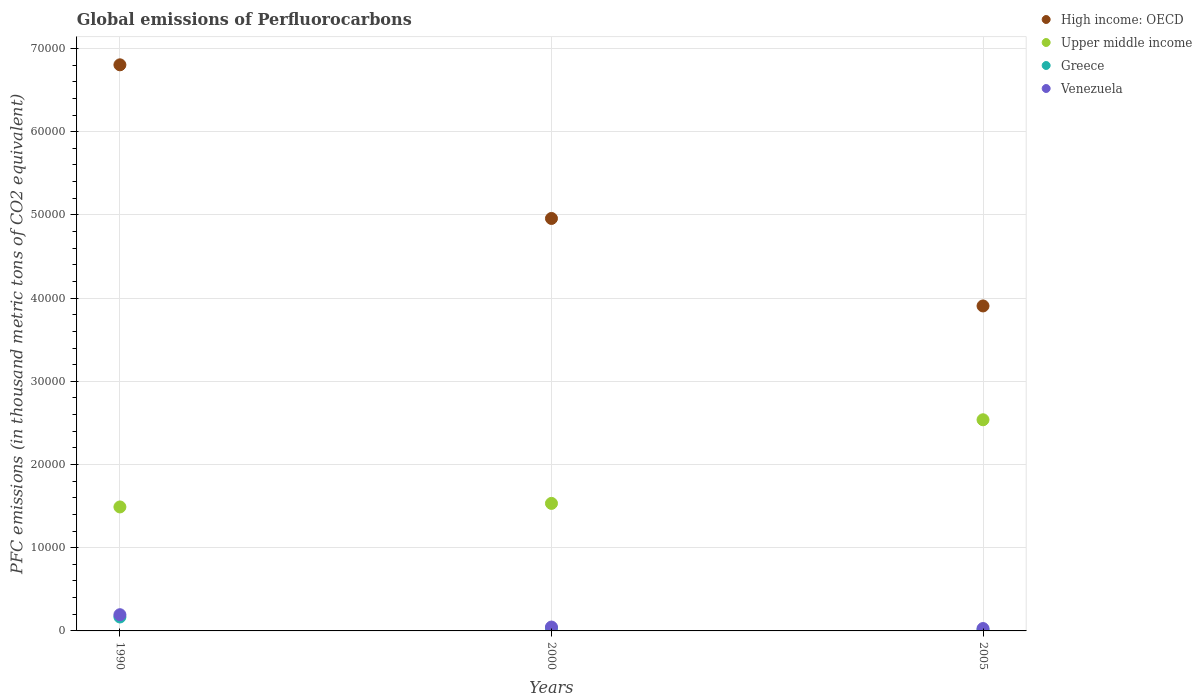Is the number of dotlines equal to the number of legend labels?
Ensure brevity in your answer.  Yes. What is the global emissions of Perfluorocarbons in Greece in 2005?
Offer a very short reply. 137.5. Across all years, what is the maximum global emissions of Perfluorocarbons in High income: OECD?
Give a very brief answer. 6.80e+04. Across all years, what is the minimum global emissions of Perfluorocarbons in High income: OECD?
Ensure brevity in your answer.  3.91e+04. In which year was the global emissions of Perfluorocarbons in Venezuela maximum?
Your response must be concise. 1990. What is the total global emissions of Perfluorocarbons in Upper middle income in the graph?
Your answer should be compact. 5.56e+04. What is the difference between the global emissions of Perfluorocarbons in High income: OECD in 1990 and that in 2005?
Provide a succinct answer. 2.90e+04. What is the difference between the global emissions of Perfluorocarbons in Upper middle income in 2005 and the global emissions of Perfluorocarbons in Venezuela in 2000?
Your response must be concise. 2.49e+04. What is the average global emissions of Perfluorocarbons in High income: OECD per year?
Make the answer very short. 5.22e+04. In the year 1990, what is the difference between the global emissions of Perfluorocarbons in High income: OECD and global emissions of Perfluorocarbons in Greece?
Give a very brief answer. 6.64e+04. In how many years, is the global emissions of Perfluorocarbons in Upper middle income greater than 8000 thousand metric tons?
Provide a succinct answer. 3. What is the ratio of the global emissions of Perfluorocarbons in Venezuela in 1990 to that in 2000?
Make the answer very short. 4.19. Is the global emissions of Perfluorocarbons in High income: OECD in 1990 less than that in 2000?
Make the answer very short. No. What is the difference between the highest and the second highest global emissions of Perfluorocarbons in Upper middle income?
Provide a short and direct response. 1.01e+04. What is the difference between the highest and the lowest global emissions of Perfluorocarbons in Upper middle income?
Your response must be concise. 1.05e+04. Is it the case that in every year, the sum of the global emissions of Perfluorocarbons in High income: OECD and global emissions of Perfluorocarbons in Upper middle income  is greater than the global emissions of Perfluorocarbons in Venezuela?
Offer a terse response. Yes. Does the global emissions of Perfluorocarbons in Upper middle income monotonically increase over the years?
Your response must be concise. Yes. How many years are there in the graph?
Provide a short and direct response. 3. What is the difference between two consecutive major ticks on the Y-axis?
Ensure brevity in your answer.  10000. Are the values on the major ticks of Y-axis written in scientific E-notation?
Your response must be concise. No. Does the graph contain any zero values?
Offer a terse response. No. Does the graph contain grids?
Your answer should be very brief. Yes. Where does the legend appear in the graph?
Your response must be concise. Top right. How are the legend labels stacked?
Keep it short and to the point. Vertical. What is the title of the graph?
Ensure brevity in your answer.  Global emissions of Perfluorocarbons. What is the label or title of the Y-axis?
Your answer should be very brief. PFC emissions (in thousand metric tons of CO2 equivalent). What is the PFC emissions (in thousand metric tons of CO2 equivalent) of High income: OECD in 1990?
Your response must be concise. 6.80e+04. What is the PFC emissions (in thousand metric tons of CO2 equivalent) in Upper middle income in 1990?
Provide a short and direct response. 1.49e+04. What is the PFC emissions (in thousand metric tons of CO2 equivalent) in Greece in 1990?
Offer a terse response. 1675.9. What is the PFC emissions (in thousand metric tons of CO2 equivalent) in Venezuela in 1990?
Offer a terse response. 1948.7. What is the PFC emissions (in thousand metric tons of CO2 equivalent) of High income: OECD in 2000?
Your answer should be compact. 4.96e+04. What is the PFC emissions (in thousand metric tons of CO2 equivalent) of Upper middle income in 2000?
Offer a terse response. 1.53e+04. What is the PFC emissions (in thousand metric tons of CO2 equivalent) of Greece in 2000?
Offer a very short reply. 311.3. What is the PFC emissions (in thousand metric tons of CO2 equivalent) in Venezuela in 2000?
Provide a short and direct response. 464.6. What is the PFC emissions (in thousand metric tons of CO2 equivalent) in High income: OECD in 2005?
Ensure brevity in your answer.  3.91e+04. What is the PFC emissions (in thousand metric tons of CO2 equivalent) of Upper middle income in 2005?
Provide a succinct answer. 2.54e+04. What is the PFC emissions (in thousand metric tons of CO2 equivalent) of Greece in 2005?
Your response must be concise. 137.5. What is the PFC emissions (in thousand metric tons of CO2 equivalent) in Venezuela in 2005?
Your response must be concise. 286.1. Across all years, what is the maximum PFC emissions (in thousand metric tons of CO2 equivalent) in High income: OECD?
Provide a short and direct response. 6.80e+04. Across all years, what is the maximum PFC emissions (in thousand metric tons of CO2 equivalent) of Upper middle income?
Give a very brief answer. 2.54e+04. Across all years, what is the maximum PFC emissions (in thousand metric tons of CO2 equivalent) of Greece?
Provide a succinct answer. 1675.9. Across all years, what is the maximum PFC emissions (in thousand metric tons of CO2 equivalent) of Venezuela?
Make the answer very short. 1948.7. Across all years, what is the minimum PFC emissions (in thousand metric tons of CO2 equivalent) of High income: OECD?
Offer a terse response. 3.91e+04. Across all years, what is the minimum PFC emissions (in thousand metric tons of CO2 equivalent) of Upper middle income?
Your answer should be compact. 1.49e+04. Across all years, what is the minimum PFC emissions (in thousand metric tons of CO2 equivalent) of Greece?
Your answer should be very brief. 137.5. Across all years, what is the minimum PFC emissions (in thousand metric tons of CO2 equivalent) in Venezuela?
Ensure brevity in your answer.  286.1. What is the total PFC emissions (in thousand metric tons of CO2 equivalent) of High income: OECD in the graph?
Offer a terse response. 1.57e+05. What is the total PFC emissions (in thousand metric tons of CO2 equivalent) of Upper middle income in the graph?
Your answer should be compact. 5.56e+04. What is the total PFC emissions (in thousand metric tons of CO2 equivalent) of Greece in the graph?
Offer a terse response. 2124.7. What is the total PFC emissions (in thousand metric tons of CO2 equivalent) of Venezuela in the graph?
Offer a terse response. 2699.4. What is the difference between the PFC emissions (in thousand metric tons of CO2 equivalent) of High income: OECD in 1990 and that in 2000?
Provide a short and direct response. 1.85e+04. What is the difference between the PFC emissions (in thousand metric tons of CO2 equivalent) in Upper middle income in 1990 and that in 2000?
Provide a succinct answer. -426.2. What is the difference between the PFC emissions (in thousand metric tons of CO2 equivalent) in Greece in 1990 and that in 2000?
Make the answer very short. 1364.6. What is the difference between the PFC emissions (in thousand metric tons of CO2 equivalent) in Venezuela in 1990 and that in 2000?
Make the answer very short. 1484.1. What is the difference between the PFC emissions (in thousand metric tons of CO2 equivalent) of High income: OECD in 1990 and that in 2005?
Make the answer very short. 2.90e+04. What is the difference between the PFC emissions (in thousand metric tons of CO2 equivalent) in Upper middle income in 1990 and that in 2005?
Provide a succinct answer. -1.05e+04. What is the difference between the PFC emissions (in thousand metric tons of CO2 equivalent) of Greece in 1990 and that in 2005?
Provide a succinct answer. 1538.4. What is the difference between the PFC emissions (in thousand metric tons of CO2 equivalent) in Venezuela in 1990 and that in 2005?
Offer a terse response. 1662.6. What is the difference between the PFC emissions (in thousand metric tons of CO2 equivalent) in High income: OECD in 2000 and that in 2005?
Offer a terse response. 1.05e+04. What is the difference between the PFC emissions (in thousand metric tons of CO2 equivalent) of Upper middle income in 2000 and that in 2005?
Offer a terse response. -1.01e+04. What is the difference between the PFC emissions (in thousand metric tons of CO2 equivalent) in Greece in 2000 and that in 2005?
Provide a succinct answer. 173.8. What is the difference between the PFC emissions (in thousand metric tons of CO2 equivalent) of Venezuela in 2000 and that in 2005?
Give a very brief answer. 178.5. What is the difference between the PFC emissions (in thousand metric tons of CO2 equivalent) in High income: OECD in 1990 and the PFC emissions (in thousand metric tons of CO2 equivalent) in Upper middle income in 2000?
Give a very brief answer. 5.27e+04. What is the difference between the PFC emissions (in thousand metric tons of CO2 equivalent) of High income: OECD in 1990 and the PFC emissions (in thousand metric tons of CO2 equivalent) of Greece in 2000?
Offer a very short reply. 6.77e+04. What is the difference between the PFC emissions (in thousand metric tons of CO2 equivalent) of High income: OECD in 1990 and the PFC emissions (in thousand metric tons of CO2 equivalent) of Venezuela in 2000?
Offer a very short reply. 6.76e+04. What is the difference between the PFC emissions (in thousand metric tons of CO2 equivalent) of Upper middle income in 1990 and the PFC emissions (in thousand metric tons of CO2 equivalent) of Greece in 2000?
Ensure brevity in your answer.  1.46e+04. What is the difference between the PFC emissions (in thousand metric tons of CO2 equivalent) of Upper middle income in 1990 and the PFC emissions (in thousand metric tons of CO2 equivalent) of Venezuela in 2000?
Provide a succinct answer. 1.44e+04. What is the difference between the PFC emissions (in thousand metric tons of CO2 equivalent) of Greece in 1990 and the PFC emissions (in thousand metric tons of CO2 equivalent) of Venezuela in 2000?
Make the answer very short. 1211.3. What is the difference between the PFC emissions (in thousand metric tons of CO2 equivalent) in High income: OECD in 1990 and the PFC emissions (in thousand metric tons of CO2 equivalent) in Upper middle income in 2005?
Keep it short and to the point. 4.27e+04. What is the difference between the PFC emissions (in thousand metric tons of CO2 equivalent) in High income: OECD in 1990 and the PFC emissions (in thousand metric tons of CO2 equivalent) in Greece in 2005?
Keep it short and to the point. 6.79e+04. What is the difference between the PFC emissions (in thousand metric tons of CO2 equivalent) of High income: OECD in 1990 and the PFC emissions (in thousand metric tons of CO2 equivalent) of Venezuela in 2005?
Provide a short and direct response. 6.77e+04. What is the difference between the PFC emissions (in thousand metric tons of CO2 equivalent) in Upper middle income in 1990 and the PFC emissions (in thousand metric tons of CO2 equivalent) in Greece in 2005?
Your answer should be compact. 1.48e+04. What is the difference between the PFC emissions (in thousand metric tons of CO2 equivalent) in Upper middle income in 1990 and the PFC emissions (in thousand metric tons of CO2 equivalent) in Venezuela in 2005?
Your response must be concise. 1.46e+04. What is the difference between the PFC emissions (in thousand metric tons of CO2 equivalent) of Greece in 1990 and the PFC emissions (in thousand metric tons of CO2 equivalent) of Venezuela in 2005?
Keep it short and to the point. 1389.8. What is the difference between the PFC emissions (in thousand metric tons of CO2 equivalent) of High income: OECD in 2000 and the PFC emissions (in thousand metric tons of CO2 equivalent) of Upper middle income in 2005?
Give a very brief answer. 2.42e+04. What is the difference between the PFC emissions (in thousand metric tons of CO2 equivalent) in High income: OECD in 2000 and the PFC emissions (in thousand metric tons of CO2 equivalent) in Greece in 2005?
Provide a short and direct response. 4.94e+04. What is the difference between the PFC emissions (in thousand metric tons of CO2 equivalent) of High income: OECD in 2000 and the PFC emissions (in thousand metric tons of CO2 equivalent) of Venezuela in 2005?
Your response must be concise. 4.93e+04. What is the difference between the PFC emissions (in thousand metric tons of CO2 equivalent) in Upper middle income in 2000 and the PFC emissions (in thousand metric tons of CO2 equivalent) in Greece in 2005?
Offer a terse response. 1.52e+04. What is the difference between the PFC emissions (in thousand metric tons of CO2 equivalent) of Upper middle income in 2000 and the PFC emissions (in thousand metric tons of CO2 equivalent) of Venezuela in 2005?
Your answer should be compact. 1.50e+04. What is the difference between the PFC emissions (in thousand metric tons of CO2 equivalent) in Greece in 2000 and the PFC emissions (in thousand metric tons of CO2 equivalent) in Venezuela in 2005?
Provide a short and direct response. 25.2. What is the average PFC emissions (in thousand metric tons of CO2 equivalent) in High income: OECD per year?
Give a very brief answer. 5.22e+04. What is the average PFC emissions (in thousand metric tons of CO2 equivalent) in Upper middle income per year?
Your response must be concise. 1.85e+04. What is the average PFC emissions (in thousand metric tons of CO2 equivalent) in Greece per year?
Make the answer very short. 708.23. What is the average PFC emissions (in thousand metric tons of CO2 equivalent) of Venezuela per year?
Your response must be concise. 899.8. In the year 1990, what is the difference between the PFC emissions (in thousand metric tons of CO2 equivalent) in High income: OECD and PFC emissions (in thousand metric tons of CO2 equivalent) in Upper middle income?
Ensure brevity in your answer.  5.31e+04. In the year 1990, what is the difference between the PFC emissions (in thousand metric tons of CO2 equivalent) of High income: OECD and PFC emissions (in thousand metric tons of CO2 equivalent) of Greece?
Offer a very short reply. 6.64e+04. In the year 1990, what is the difference between the PFC emissions (in thousand metric tons of CO2 equivalent) in High income: OECD and PFC emissions (in thousand metric tons of CO2 equivalent) in Venezuela?
Ensure brevity in your answer.  6.61e+04. In the year 1990, what is the difference between the PFC emissions (in thousand metric tons of CO2 equivalent) in Upper middle income and PFC emissions (in thousand metric tons of CO2 equivalent) in Greece?
Give a very brief answer. 1.32e+04. In the year 1990, what is the difference between the PFC emissions (in thousand metric tons of CO2 equivalent) in Upper middle income and PFC emissions (in thousand metric tons of CO2 equivalent) in Venezuela?
Ensure brevity in your answer.  1.30e+04. In the year 1990, what is the difference between the PFC emissions (in thousand metric tons of CO2 equivalent) of Greece and PFC emissions (in thousand metric tons of CO2 equivalent) of Venezuela?
Your answer should be very brief. -272.8. In the year 2000, what is the difference between the PFC emissions (in thousand metric tons of CO2 equivalent) in High income: OECD and PFC emissions (in thousand metric tons of CO2 equivalent) in Upper middle income?
Provide a succinct answer. 3.42e+04. In the year 2000, what is the difference between the PFC emissions (in thousand metric tons of CO2 equivalent) of High income: OECD and PFC emissions (in thousand metric tons of CO2 equivalent) of Greece?
Provide a short and direct response. 4.93e+04. In the year 2000, what is the difference between the PFC emissions (in thousand metric tons of CO2 equivalent) of High income: OECD and PFC emissions (in thousand metric tons of CO2 equivalent) of Venezuela?
Ensure brevity in your answer.  4.91e+04. In the year 2000, what is the difference between the PFC emissions (in thousand metric tons of CO2 equivalent) of Upper middle income and PFC emissions (in thousand metric tons of CO2 equivalent) of Greece?
Offer a terse response. 1.50e+04. In the year 2000, what is the difference between the PFC emissions (in thousand metric tons of CO2 equivalent) in Upper middle income and PFC emissions (in thousand metric tons of CO2 equivalent) in Venezuela?
Offer a very short reply. 1.49e+04. In the year 2000, what is the difference between the PFC emissions (in thousand metric tons of CO2 equivalent) in Greece and PFC emissions (in thousand metric tons of CO2 equivalent) in Venezuela?
Keep it short and to the point. -153.3. In the year 2005, what is the difference between the PFC emissions (in thousand metric tons of CO2 equivalent) of High income: OECD and PFC emissions (in thousand metric tons of CO2 equivalent) of Upper middle income?
Provide a succinct answer. 1.37e+04. In the year 2005, what is the difference between the PFC emissions (in thousand metric tons of CO2 equivalent) of High income: OECD and PFC emissions (in thousand metric tons of CO2 equivalent) of Greece?
Make the answer very short. 3.89e+04. In the year 2005, what is the difference between the PFC emissions (in thousand metric tons of CO2 equivalent) of High income: OECD and PFC emissions (in thousand metric tons of CO2 equivalent) of Venezuela?
Make the answer very short. 3.88e+04. In the year 2005, what is the difference between the PFC emissions (in thousand metric tons of CO2 equivalent) in Upper middle income and PFC emissions (in thousand metric tons of CO2 equivalent) in Greece?
Offer a very short reply. 2.52e+04. In the year 2005, what is the difference between the PFC emissions (in thousand metric tons of CO2 equivalent) in Upper middle income and PFC emissions (in thousand metric tons of CO2 equivalent) in Venezuela?
Keep it short and to the point. 2.51e+04. In the year 2005, what is the difference between the PFC emissions (in thousand metric tons of CO2 equivalent) of Greece and PFC emissions (in thousand metric tons of CO2 equivalent) of Venezuela?
Give a very brief answer. -148.6. What is the ratio of the PFC emissions (in thousand metric tons of CO2 equivalent) of High income: OECD in 1990 to that in 2000?
Offer a very short reply. 1.37. What is the ratio of the PFC emissions (in thousand metric tons of CO2 equivalent) of Upper middle income in 1990 to that in 2000?
Make the answer very short. 0.97. What is the ratio of the PFC emissions (in thousand metric tons of CO2 equivalent) in Greece in 1990 to that in 2000?
Give a very brief answer. 5.38. What is the ratio of the PFC emissions (in thousand metric tons of CO2 equivalent) of Venezuela in 1990 to that in 2000?
Provide a succinct answer. 4.19. What is the ratio of the PFC emissions (in thousand metric tons of CO2 equivalent) of High income: OECD in 1990 to that in 2005?
Provide a succinct answer. 1.74. What is the ratio of the PFC emissions (in thousand metric tons of CO2 equivalent) of Upper middle income in 1990 to that in 2005?
Your answer should be compact. 0.59. What is the ratio of the PFC emissions (in thousand metric tons of CO2 equivalent) in Greece in 1990 to that in 2005?
Provide a succinct answer. 12.19. What is the ratio of the PFC emissions (in thousand metric tons of CO2 equivalent) of Venezuela in 1990 to that in 2005?
Offer a terse response. 6.81. What is the ratio of the PFC emissions (in thousand metric tons of CO2 equivalent) in High income: OECD in 2000 to that in 2005?
Provide a succinct answer. 1.27. What is the ratio of the PFC emissions (in thousand metric tons of CO2 equivalent) in Upper middle income in 2000 to that in 2005?
Keep it short and to the point. 0.6. What is the ratio of the PFC emissions (in thousand metric tons of CO2 equivalent) of Greece in 2000 to that in 2005?
Make the answer very short. 2.26. What is the ratio of the PFC emissions (in thousand metric tons of CO2 equivalent) of Venezuela in 2000 to that in 2005?
Provide a succinct answer. 1.62. What is the difference between the highest and the second highest PFC emissions (in thousand metric tons of CO2 equivalent) of High income: OECD?
Your answer should be very brief. 1.85e+04. What is the difference between the highest and the second highest PFC emissions (in thousand metric tons of CO2 equivalent) of Upper middle income?
Provide a short and direct response. 1.01e+04. What is the difference between the highest and the second highest PFC emissions (in thousand metric tons of CO2 equivalent) of Greece?
Offer a very short reply. 1364.6. What is the difference between the highest and the second highest PFC emissions (in thousand metric tons of CO2 equivalent) of Venezuela?
Ensure brevity in your answer.  1484.1. What is the difference between the highest and the lowest PFC emissions (in thousand metric tons of CO2 equivalent) of High income: OECD?
Offer a terse response. 2.90e+04. What is the difference between the highest and the lowest PFC emissions (in thousand metric tons of CO2 equivalent) in Upper middle income?
Your answer should be compact. 1.05e+04. What is the difference between the highest and the lowest PFC emissions (in thousand metric tons of CO2 equivalent) in Greece?
Provide a succinct answer. 1538.4. What is the difference between the highest and the lowest PFC emissions (in thousand metric tons of CO2 equivalent) of Venezuela?
Keep it short and to the point. 1662.6. 